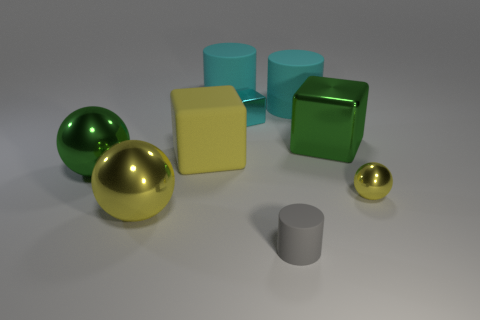Subtract all small cylinders. How many cylinders are left? 2 Add 1 large cyan cylinders. How many objects exist? 10 Subtract all green blocks. How many blocks are left? 2 Subtract 1 balls. How many balls are left? 2 Subtract all cylinders. How many objects are left? 6 Subtract all cyan balls. Subtract all green cubes. How many balls are left? 3 Subtract all purple balls. How many yellow cubes are left? 1 Subtract all large green shiny spheres. Subtract all big cyan rubber cylinders. How many objects are left? 6 Add 2 matte cubes. How many matte cubes are left? 3 Add 1 large yellow balls. How many large yellow balls exist? 2 